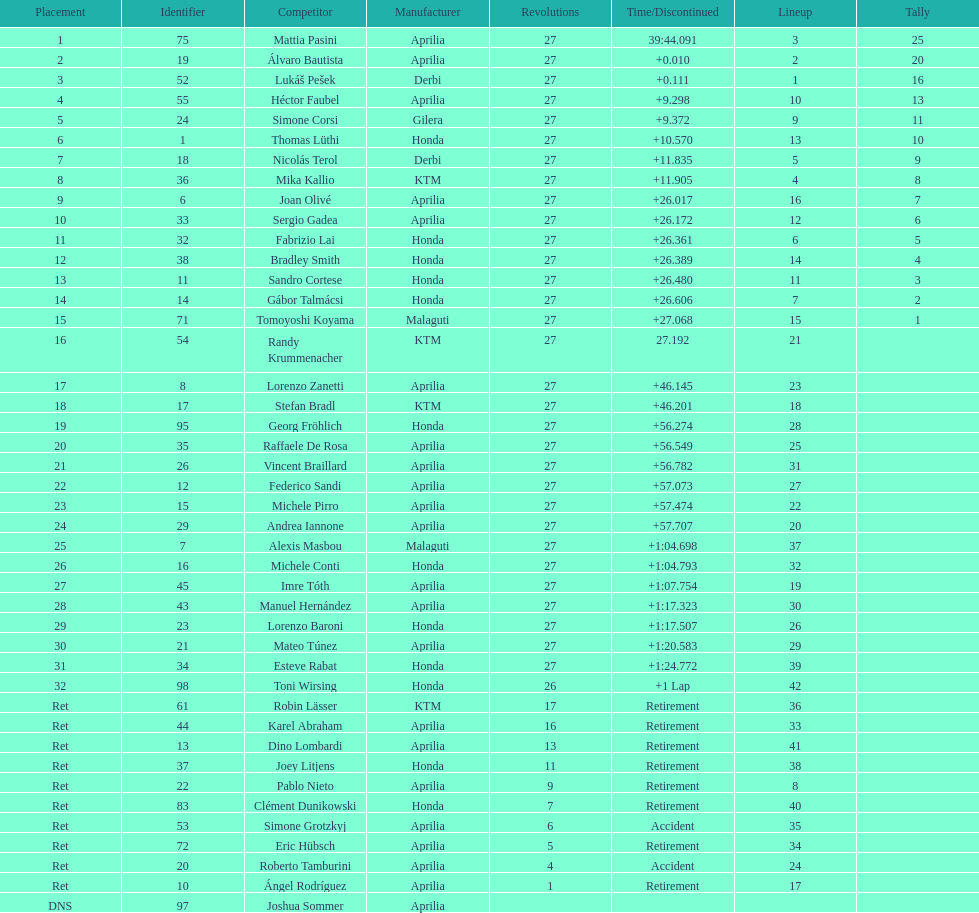How many german racers finished the race? 4. 